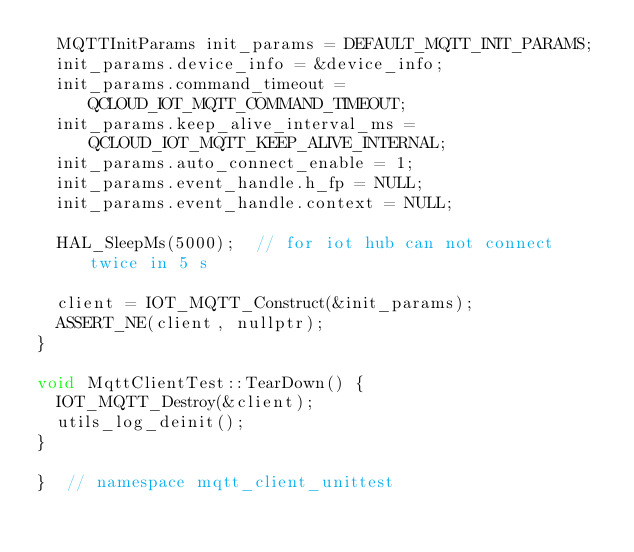Convert code to text. <code><loc_0><loc_0><loc_500><loc_500><_C++_>  MQTTInitParams init_params = DEFAULT_MQTT_INIT_PARAMS;
  init_params.device_info = &device_info;
  init_params.command_timeout = QCLOUD_IOT_MQTT_COMMAND_TIMEOUT;
  init_params.keep_alive_interval_ms = QCLOUD_IOT_MQTT_KEEP_ALIVE_INTERNAL;
  init_params.auto_connect_enable = 1;
  init_params.event_handle.h_fp = NULL;
  init_params.event_handle.context = NULL;

  HAL_SleepMs(5000);  // for iot hub can not connect twice in 5 s

  client = IOT_MQTT_Construct(&init_params);
  ASSERT_NE(client, nullptr);
}

void MqttClientTest::TearDown() {
  IOT_MQTT_Destroy(&client);
  utils_log_deinit();
}

}  // namespace mqtt_client_unittest
</code> 